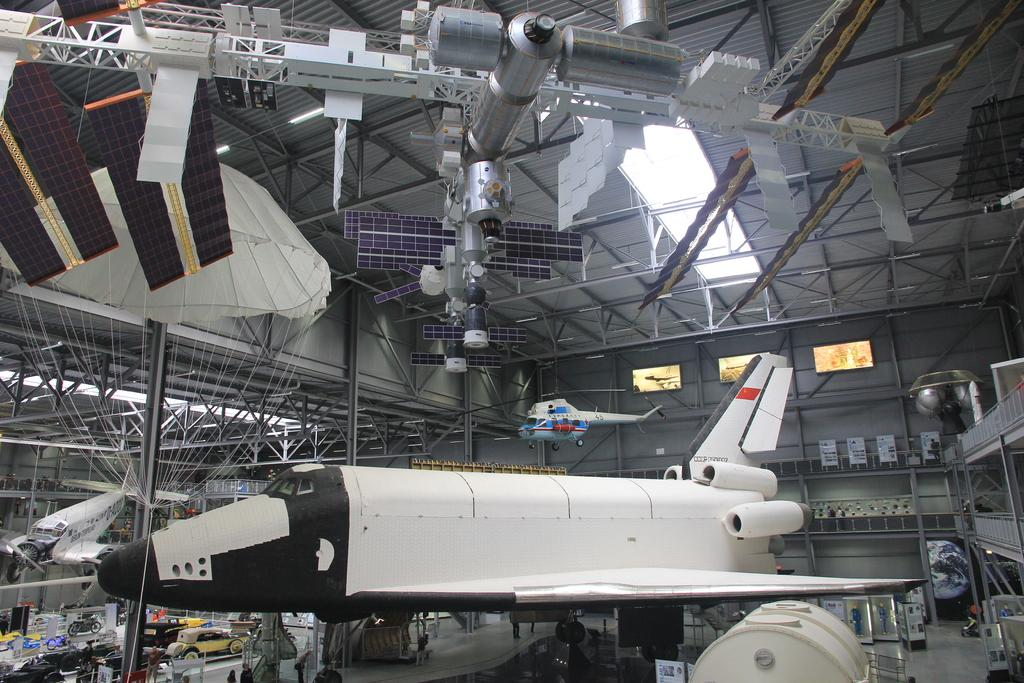Where was the image taken? The image was captured inside a "technik museum." What can be seen in the room where the image was taken? There are many planes and electronic equipment in the room. Is there any popcorn being served at the birthday party in the image? There is no mention of a birthday party or popcorn in the image or the provided facts. 